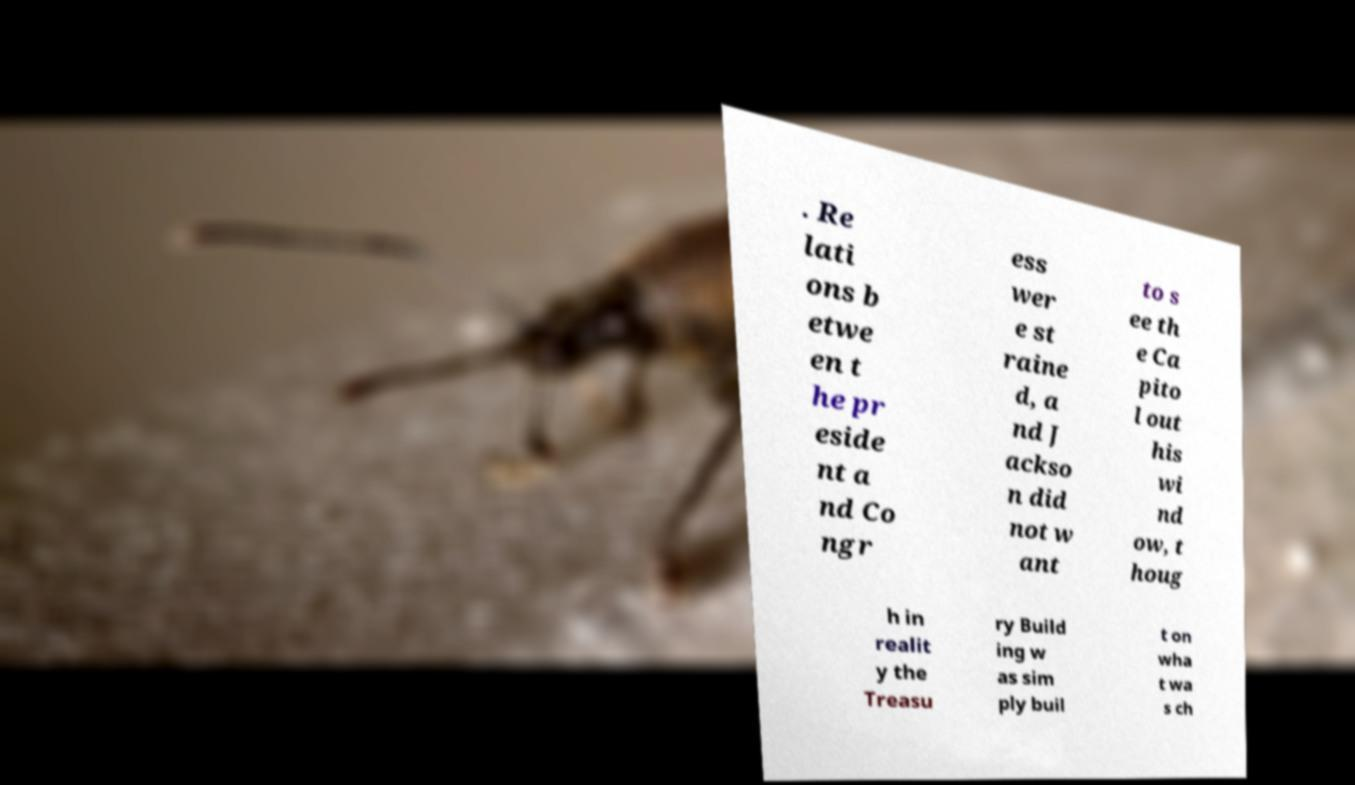Could you assist in decoding the text presented in this image and type it out clearly? . Re lati ons b etwe en t he pr eside nt a nd Co ngr ess wer e st raine d, a nd J ackso n did not w ant to s ee th e Ca pito l out his wi nd ow, t houg h in realit y the Treasu ry Build ing w as sim ply buil t on wha t wa s ch 